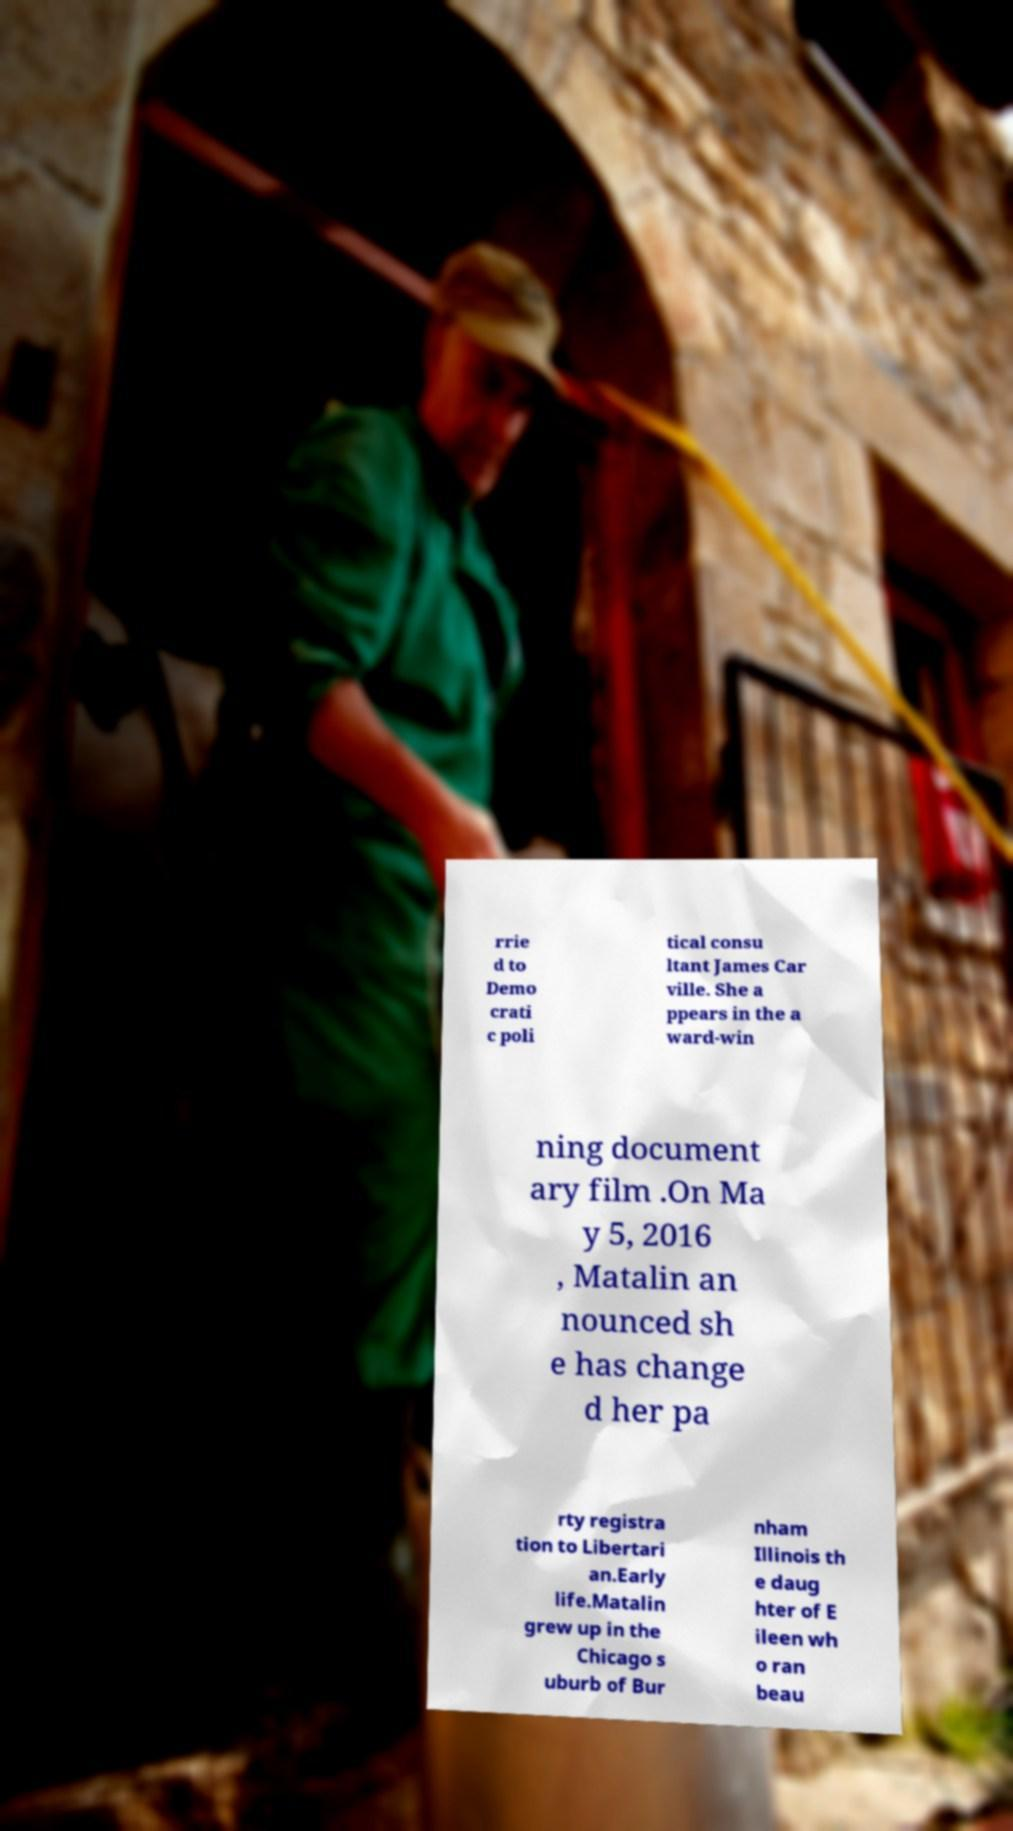Please identify and transcribe the text found in this image. rrie d to Demo crati c poli tical consu ltant James Car ville. She a ppears in the a ward-win ning document ary film .On Ma y 5, 2016 , Matalin an nounced sh e has change d her pa rty registra tion to Libertari an.Early life.Matalin grew up in the Chicago s uburb of Bur nham Illinois th e daug hter of E ileen wh o ran beau 